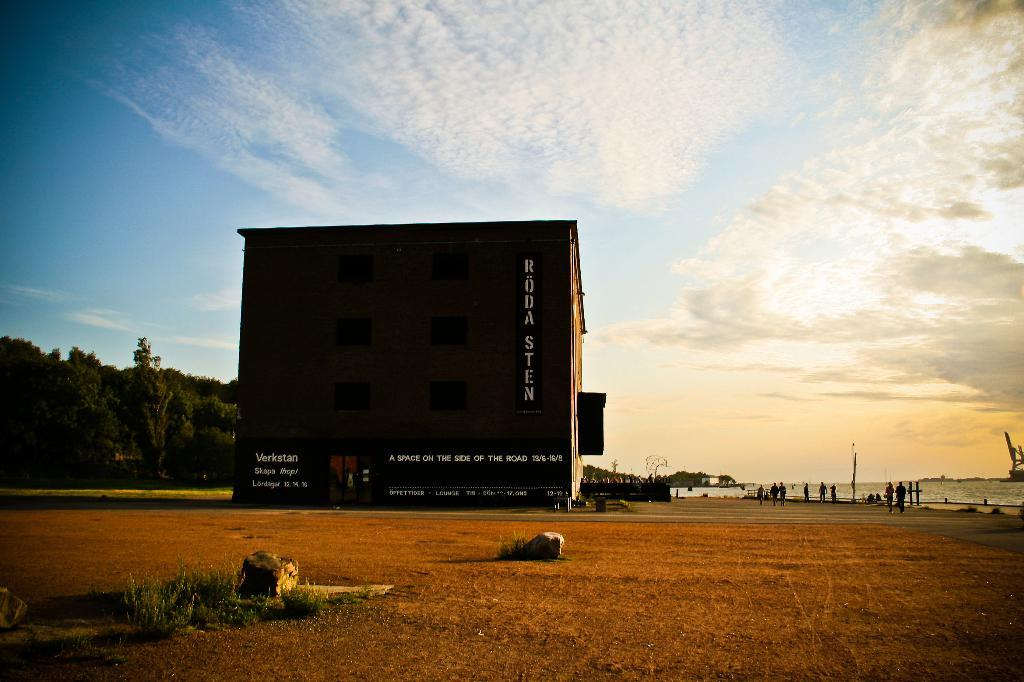What type of natural environment is visible in the image? There is grass in the image, which suggests a natural environment. What type of structure is present in the image? There is a building in the image. What other natural elements can be seen in the image? There are trees in the image. What is visible in the sky in the image? There are clouds in the image. What part of the sky is visible in the image? The sky is visible in the image. Are there any people present in the image? Yes, there are people standing in the image. Is there any text or writing visible in the image? Yes, there is text or writing visible in the image. What type of prison can be seen in the image? There is no prison present in the image. How long do the people need to rest in the image? There is no indication in the image that the people need to rest, and therefore no such information can be determined. 